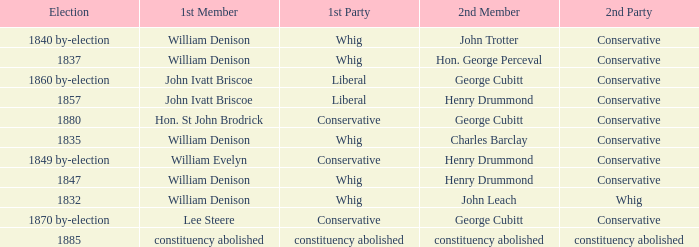Which party's 1st member is William Denison in the election of 1832? Whig. 